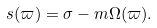<formula> <loc_0><loc_0><loc_500><loc_500>s ( \varpi ) = \sigma - m \Omega ( \varpi ) .</formula> 